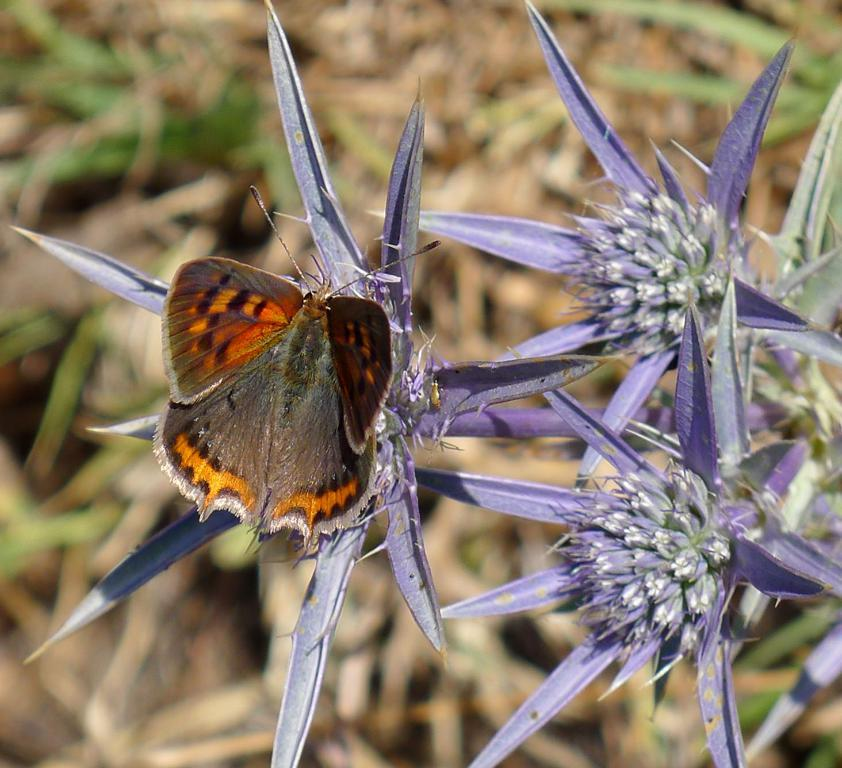What is the main subject of the image? There is a bug in the image. Where is the bug located? The bug is sitting on a flower. Can you describe the background of the image? The background of the image is blurred. What type of skirt is the bug wearing in the image? There is no skirt present in the image, as the subject is a bug and not a person. 